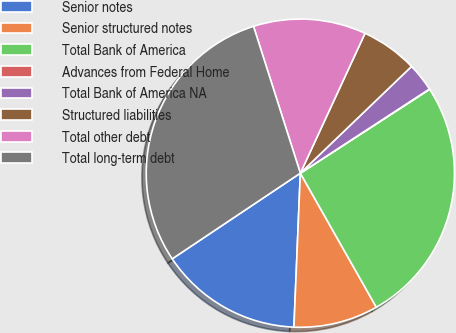<chart> <loc_0><loc_0><loc_500><loc_500><pie_chart><fcel>Senior notes<fcel>Senior structured notes<fcel>Total Bank of America<fcel>Advances from Federal Home<fcel>Total Bank of America NA<fcel>Structured liabilities<fcel>Total other debt<fcel>Total long-term debt<nl><fcel>14.96%<fcel>8.87%<fcel>25.95%<fcel>0.04%<fcel>2.98%<fcel>5.93%<fcel>11.81%<fcel>29.47%<nl></chart> 